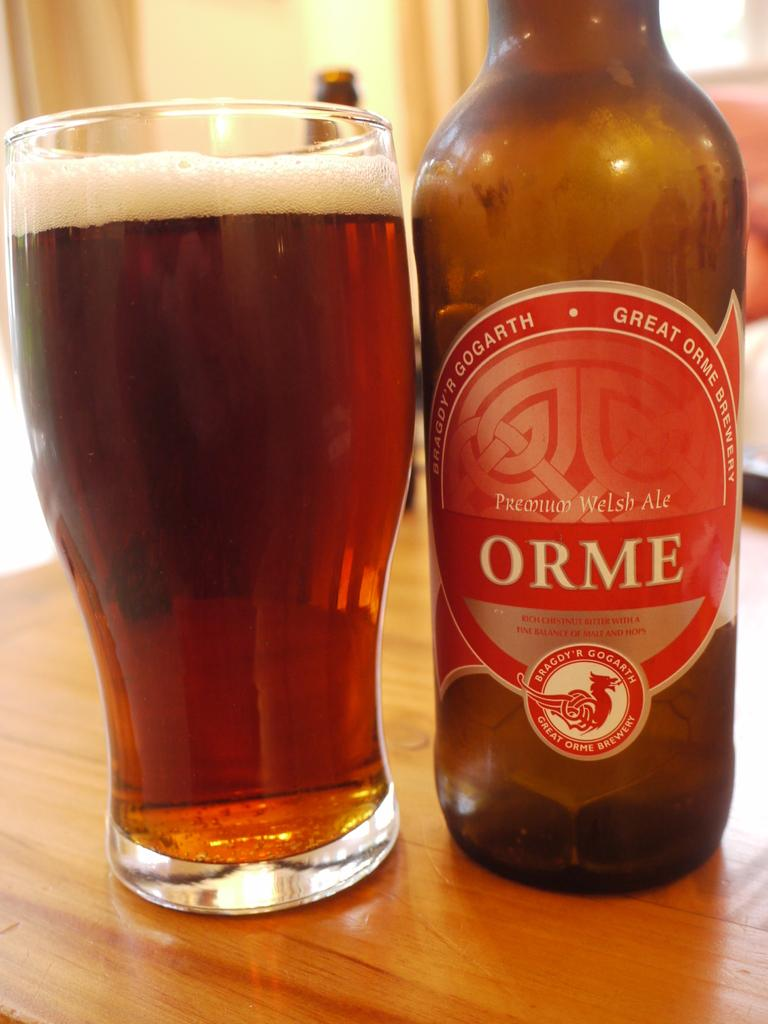<image>
Render a clear and concise summary of the photo. Great Orme Beer poured into a large cup that says Premium Welsh Ale. 